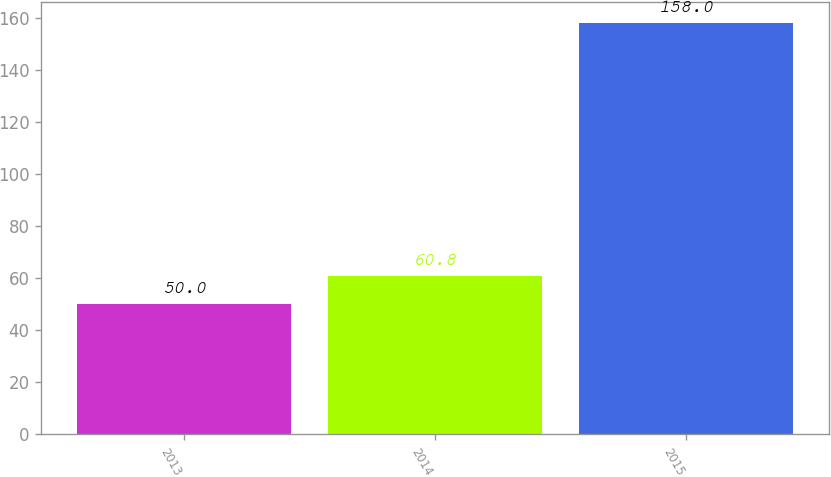<chart> <loc_0><loc_0><loc_500><loc_500><bar_chart><fcel>2013<fcel>2014<fcel>2015<nl><fcel>50<fcel>60.8<fcel>158<nl></chart> 